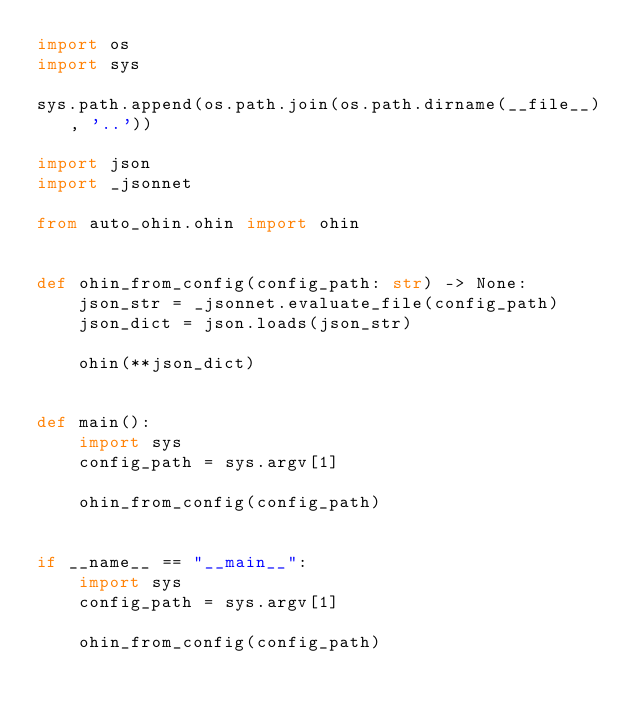Convert code to text. <code><loc_0><loc_0><loc_500><loc_500><_Python_>import os
import sys

sys.path.append(os.path.join(os.path.dirname(__file__), '..'))

import json
import _jsonnet

from auto_ohin.ohin import ohin


def ohin_from_config(config_path: str) -> None:
    json_str = _jsonnet.evaluate_file(config_path)
    json_dict = json.loads(json_str)

    ohin(**json_dict)


def main():
    import sys
    config_path = sys.argv[1]

    ohin_from_config(config_path)


if __name__ == "__main__":
    import sys
    config_path = sys.argv[1]

    ohin_from_config(config_path)
</code> 